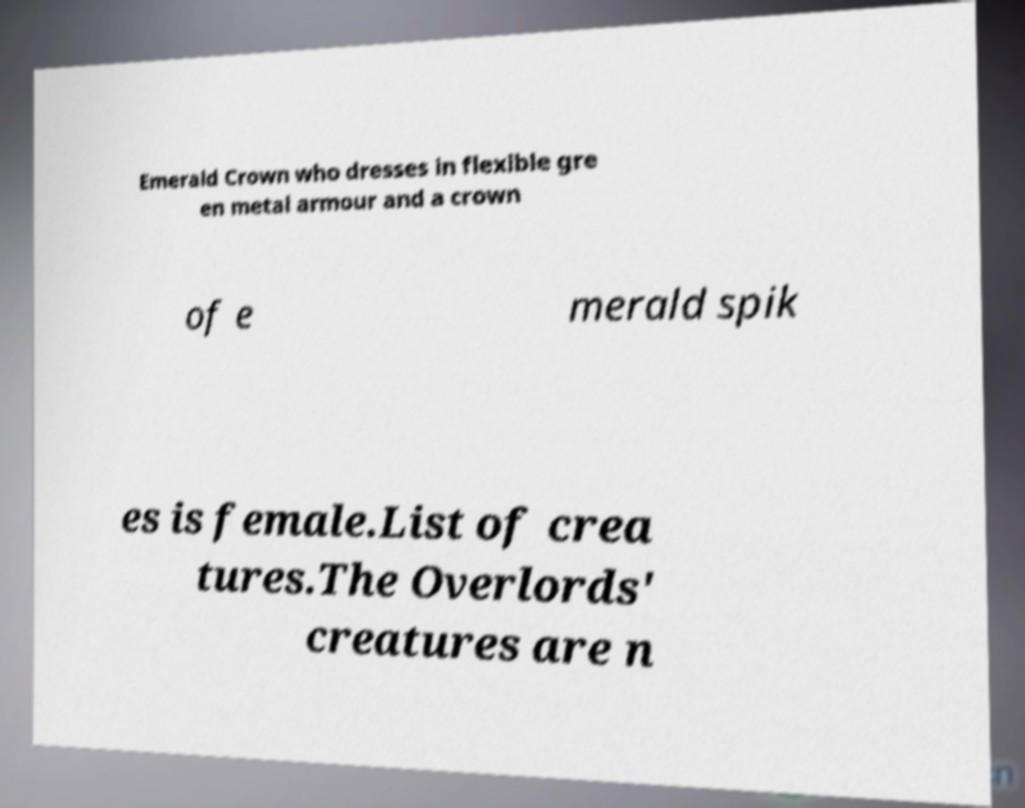Can you accurately transcribe the text from the provided image for me? Emerald Crown who dresses in flexible gre en metal armour and a crown of e merald spik es is female.List of crea tures.The Overlords' creatures are n 